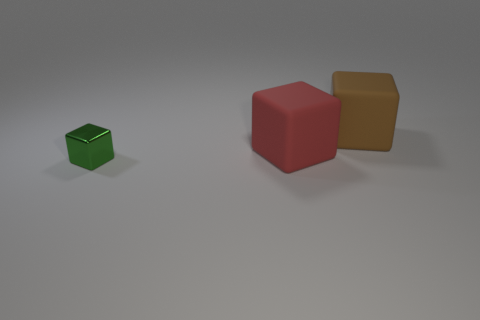How many objects are in front of the large brown matte block and right of the small green metal cube? 1 